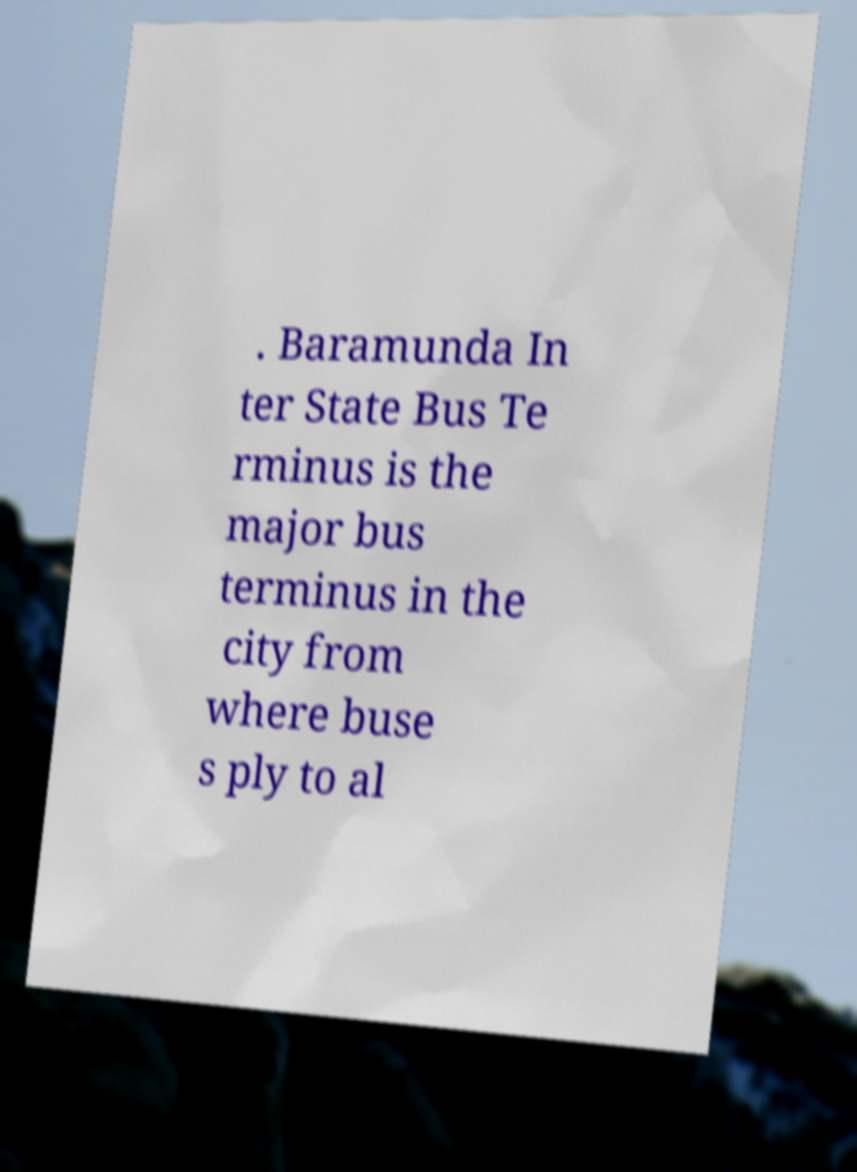Can you accurately transcribe the text from the provided image for me? . Baramunda In ter State Bus Te rminus is the major bus terminus in the city from where buse s ply to al 